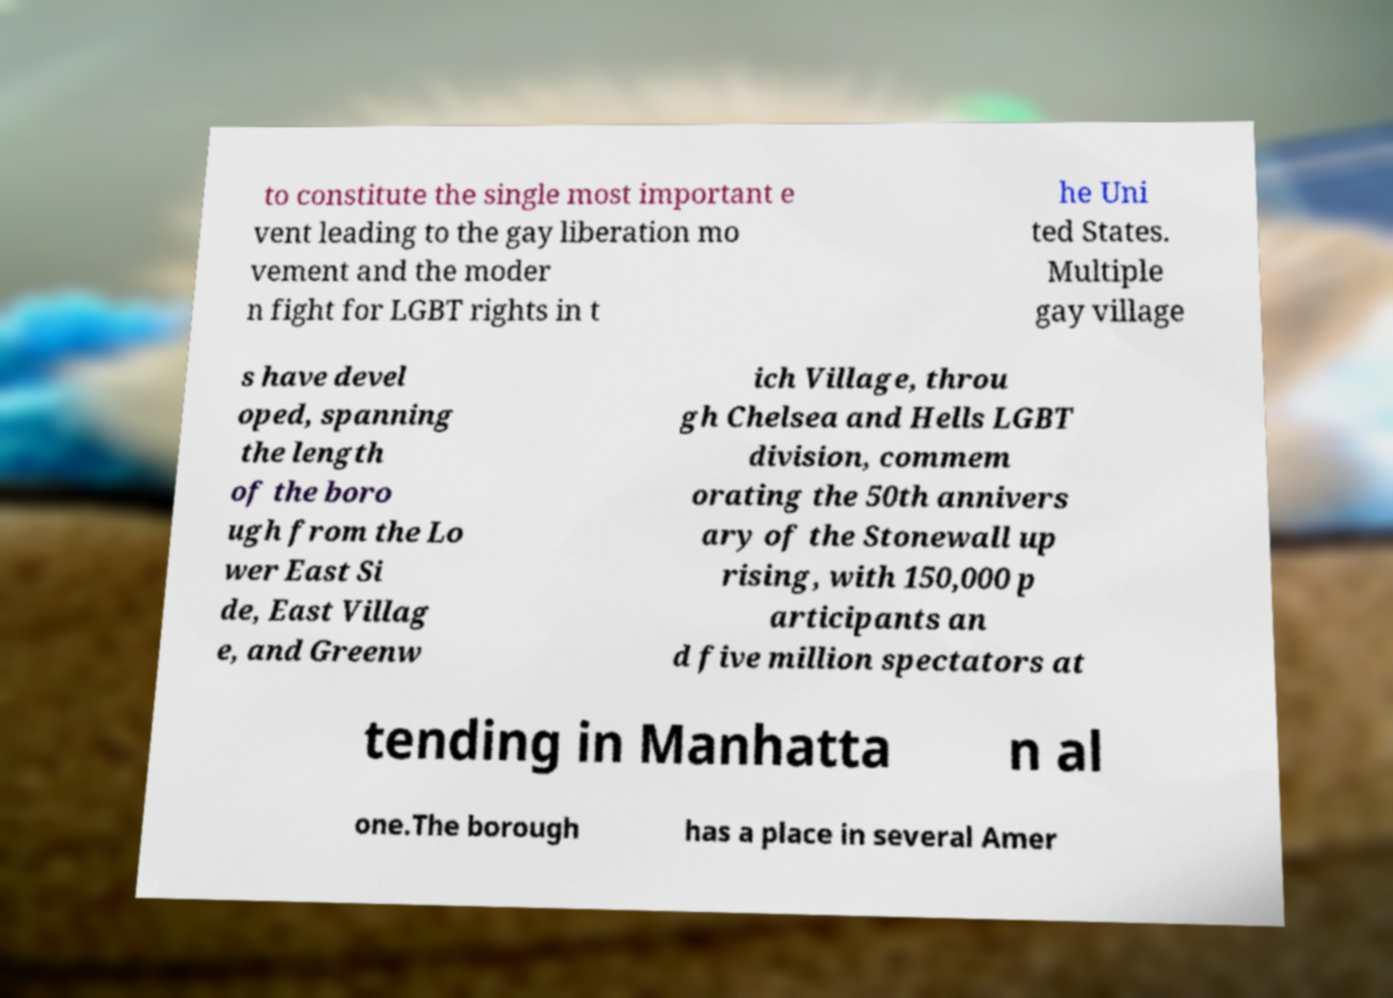I need the written content from this picture converted into text. Can you do that? to constitute the single most important e vent leading to the gay liberation mo vement and the moder n fight for LGBT rights in t he Uni ted States. Multiple gay village s have devel oped, spanning the length of the boro ugh from the Lo wer East Si de, East Villag e, and Greenw ich Village, throu gh Chelsea and Hells LGBT division, commem orating the 50th annivers ary of the Stonewall up rising, with 150,000 p articipants an d five million spectators at tending in Manhatta n al one.The borough has a place in several Amer 